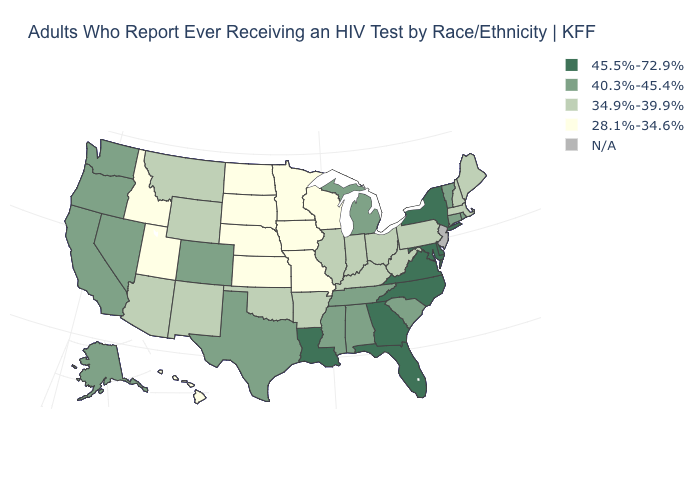Name the states that have a value in the range 28.1%-34.6%?
Give a very brief answer. Hawaii, Idaho, Iowa, Kansas, Minnesota, Missouri, Nebraska, North Dakota, South Dakota, Utah, Wisconsin. What is the value of Virginia?
Short answer required. 45.5%-72.9%. Name the states that have a value in the range 45.5%-72.9%?
Answer briefly. Delaware, Florida, Georgia, Louisiana, Maryland, New York, North Carolina, Virginia. What is the value of Rhode Island?
Give a very brief answer. 40.3%-45.4%. Among the states that border Oregon , does Nevada have the highest value?
Write a very short answer. Yes. Which states have the highest value in the USA?
Be succinct. Delaware, Florida, Georgia, Louisiana, Maryland, New York, North Carolina, Virginia. Name the states that have a value in the range N/A?
Short answer required. New Jersey. Does the map have missing data?
Quick response, please. Yes. Name the states that have a value in the range 40.3%-45.4%?
Answer briefly. Alabama, Alaska, California, Colorado, Connecticut, Michigan, Mississippi, Nevada, Oregon, Rhode Island, South Carolina, Tennessee, Texas, Vermont, Washington. What is the value of Montana?
Short answer required. 34.9%-39.9%. What is the value of West Virginia?
Be succinct. 34.9%-39.9%. Among the states that border Kentucky , which have the lowest value?
Answer briefly. Missouri. What is the highest value in the South ?
Answer briefly. 45.5%-72.9%. 